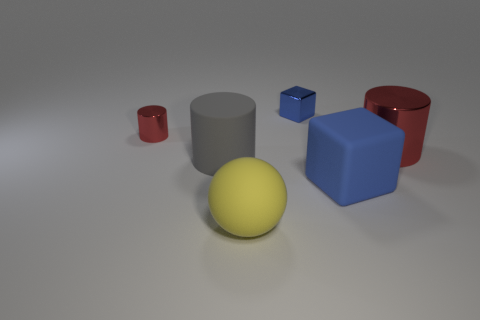Subtract all red cylinders. How many were subtracted if there are1red cylinders left? 1 Subtract all small cylinders. How many cylinders are left? 2 Subtract all gray cylinders. How many cylinders are left? 2 Subtract all blocks. How many objects are left? 4 Subtract 2 cubes. How many cubes are left? 0 Subtract all yellow spheres. How many red blocks are left? 0 Subtract all big blue matte cylinders. Subtract all gray matte objects. How many objects are left? 5 Add 3 large gray rubber cylinders. How many large gray rubber cylinders are left? 4 Add 2 gray shiny cubes. How many gray shiny cubes exist? 2 Add 4 big brown things. How many objects exist? 10 